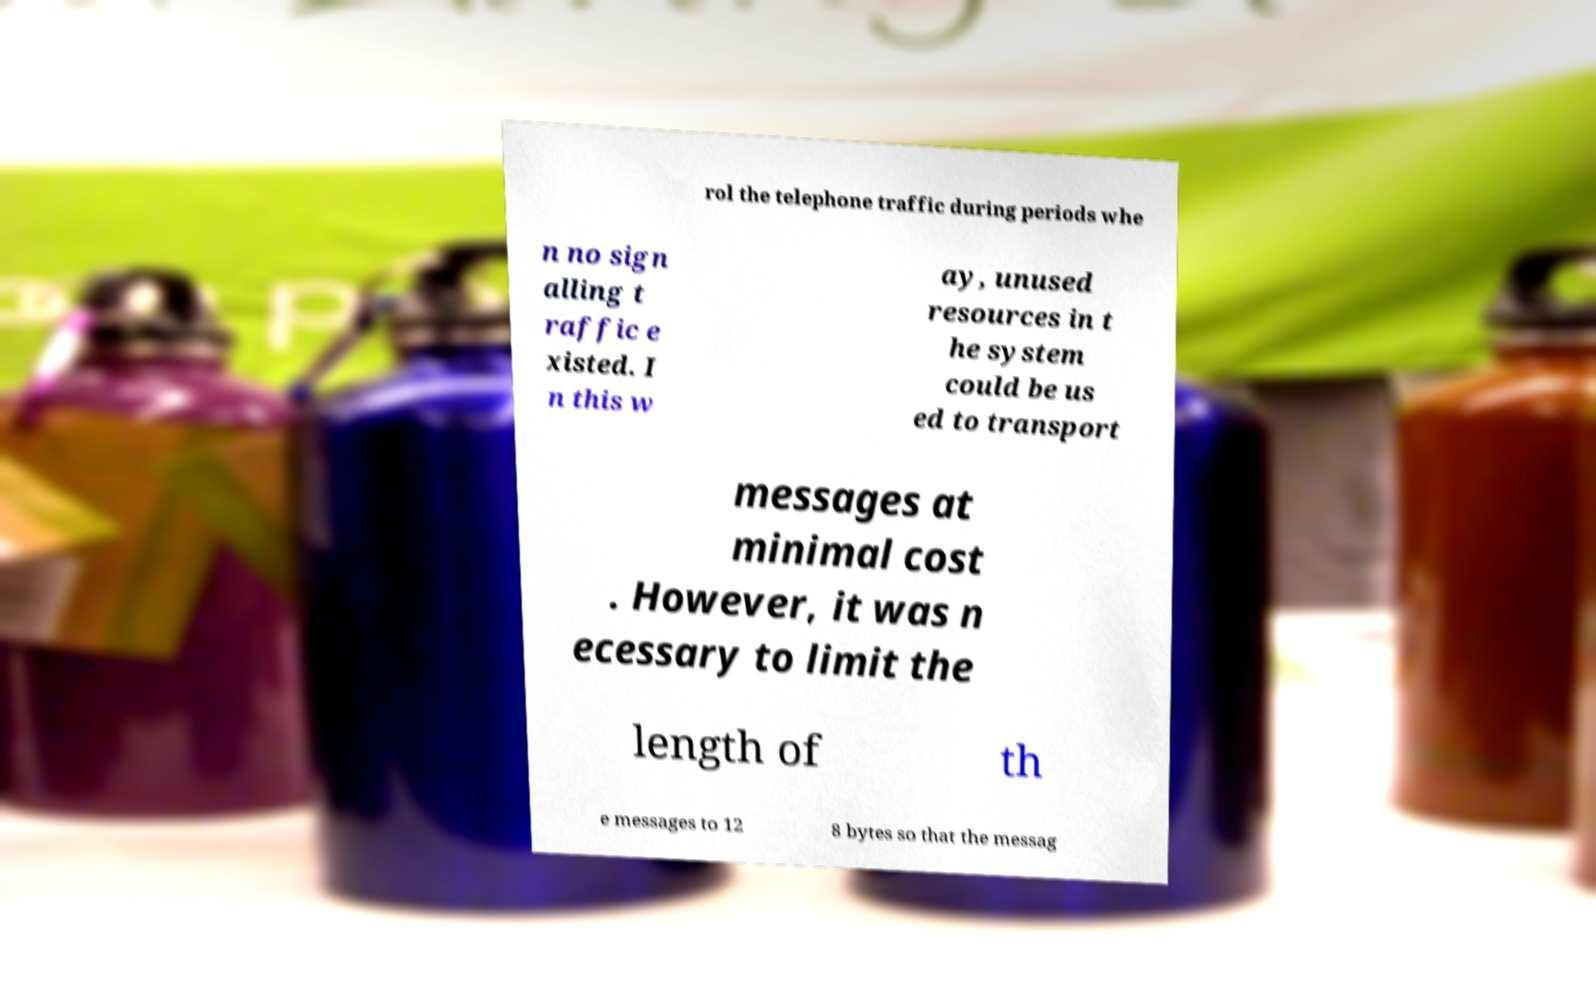Can you accurately transcribe the text from the provided image for me? rol the telephone traffic during periods whe n no sign alling t raffic e xisted. I n this w ay, unused resources in t he system could be us ed to transport messages at minimal cost . However, it was n ecessary to limit the length of th e messages to 12 8 bytes so that the messag 